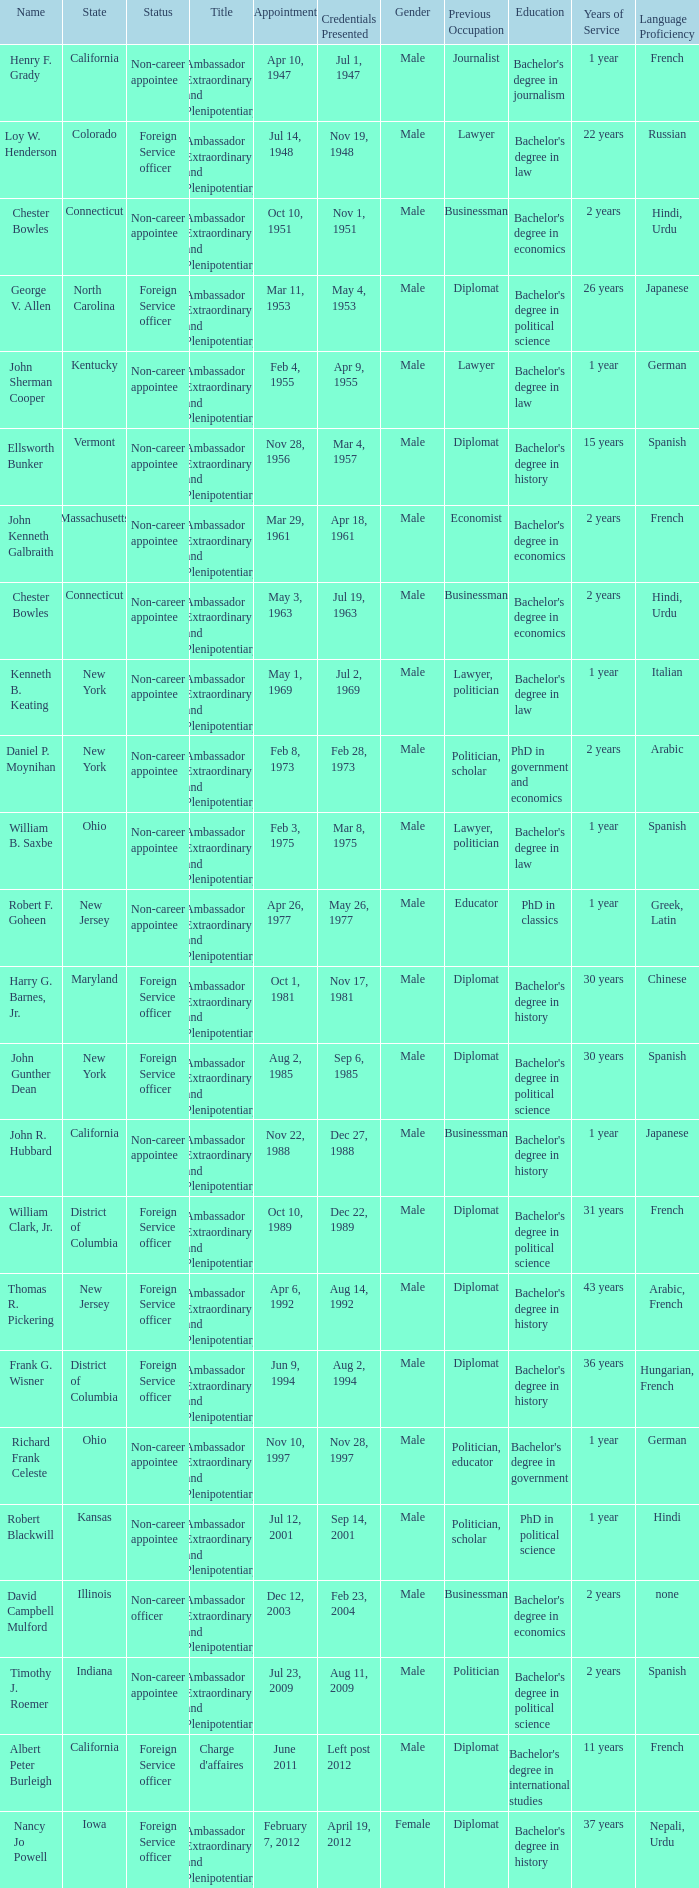What day was the appointment when Credentials Presented was jul 2, 1969? May 1, 1969. 